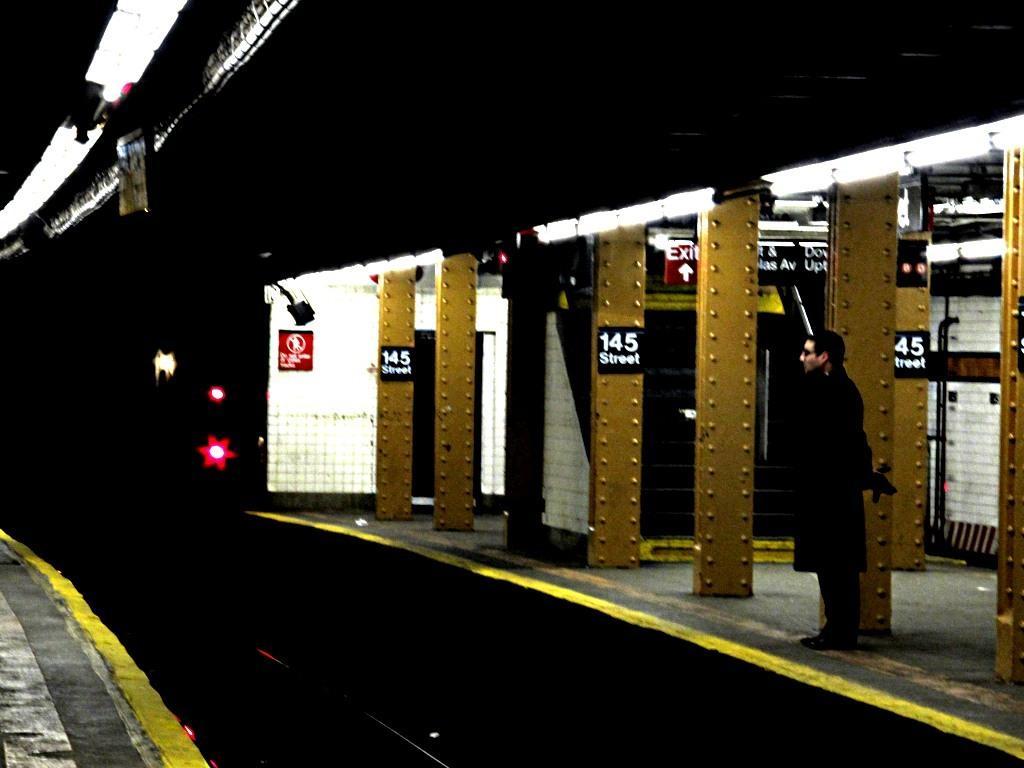How would you summarize this image in a sentence or two? This is the picture of a railway station. In this image there is a person standing on the platform. At the back there are boards on the wall and on the pillars and there is text on the boards. At the top there are lights. 